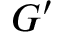Convert formula to latex. <formula><loc_0><loc_0><loc_500><loc_500>G ^ { \prime }</formula> 